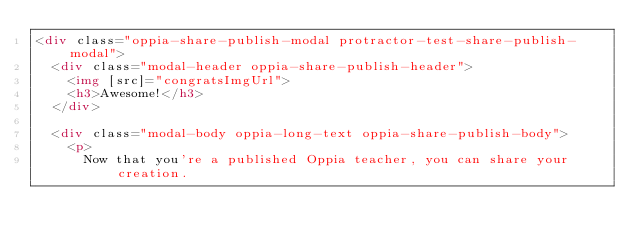<code> <loc_0><loc_0><loc_500><loc_500><_HTML_><div class="oppia-share-publish-modal protractor-test-share-publish-modal">
  <div class="modal-header oppia-share-publish-header">
    <img [src]="congratsImgUrl">
    <h3>Awesome!</h3>
  </div>

  <div class="modal-body oppia-long-text oppia-share-publish-body">
    <p>
      Now that you're a published Oppia teacher, you can share your creation.</code> 